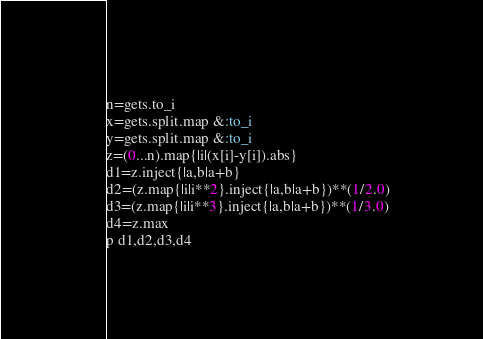<code> <loc_0><loc_0><loc_500><loc_500><_Ruby_>n=gets.to_i
x=gets.split.map &:to_i
y=gets.split.map &:to_i
z=(0...n).map{|i|(x[i]-y[i]).abs}
d1=z.inject{|a,b|a+b}
d2=(z.map{|i|i**2}.inject{|a,b|a+b})**(1/2.0)
d3=(z.map{|i|i**3}.inject{|a,b|a+b})**(1/3.0)
d4=z.max
p d1,d2,d3,d4
</code> 